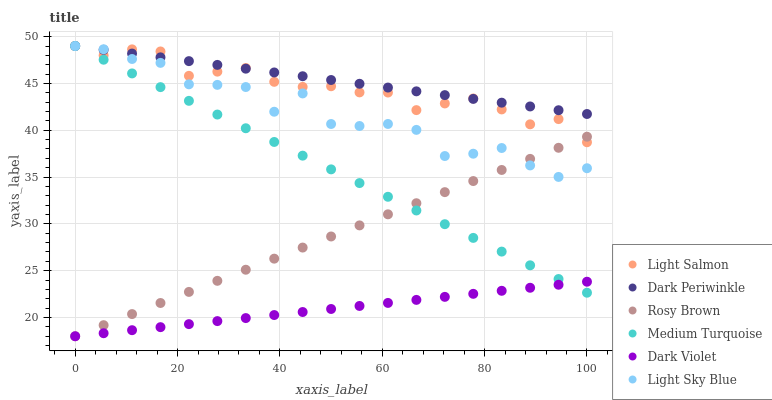Does Dark Violet have the minimum area under the curve?
Answer yes or no. Yes. Does Dark Periwinkle have the maximum area under the curve?
Answer yes or no. Yes. Does Rosy Brown have the minimum area under the curve?
Answer yes or no. No. Does Rosy Brown have the maximum area under the curve?
Answer yes or no. No. Is Dark Violet the smoothest?
Answer yes or no. Yes. Is Light Sky Blue the roughest?
Answer yes or no. Yes. Is Rosy Brown the smoothest?
Answer yes or no. No. Is Rosy Brown the roughest?
Answer yes or no. No. Does Rosy Brown have the lowest value?
Answer yes or no. Yes. Does Light Sky Blue have the lowest value?
Answer yes or no. No. Does Dark Periwinkle have the highest value?
Answer yes or no. Yes. Does Rosy Brown have the highest value?
Answer yes or no. No. Is Dark Violet less than Light Salmon?
Answer yes or no. Yes. Is Dark Periwinkle greater than Dark Violet?
Answer yes or no. Yes. Does Light Salmon intersect Light Sky Blue?
Answer yes or no. Yes. Is Light Salmon less than Light Sky Blue?
Answer yes or no. No. Is Light Salmon greater than Light Sky Blue?
Answer yes or no. No. Does Dark Violet intersect Light Salmon?
Answer yes or no. No. 